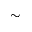Convert formula to latex. <formula><loc_0><loc_0><loc_500><loc_500>\sim</formula> 